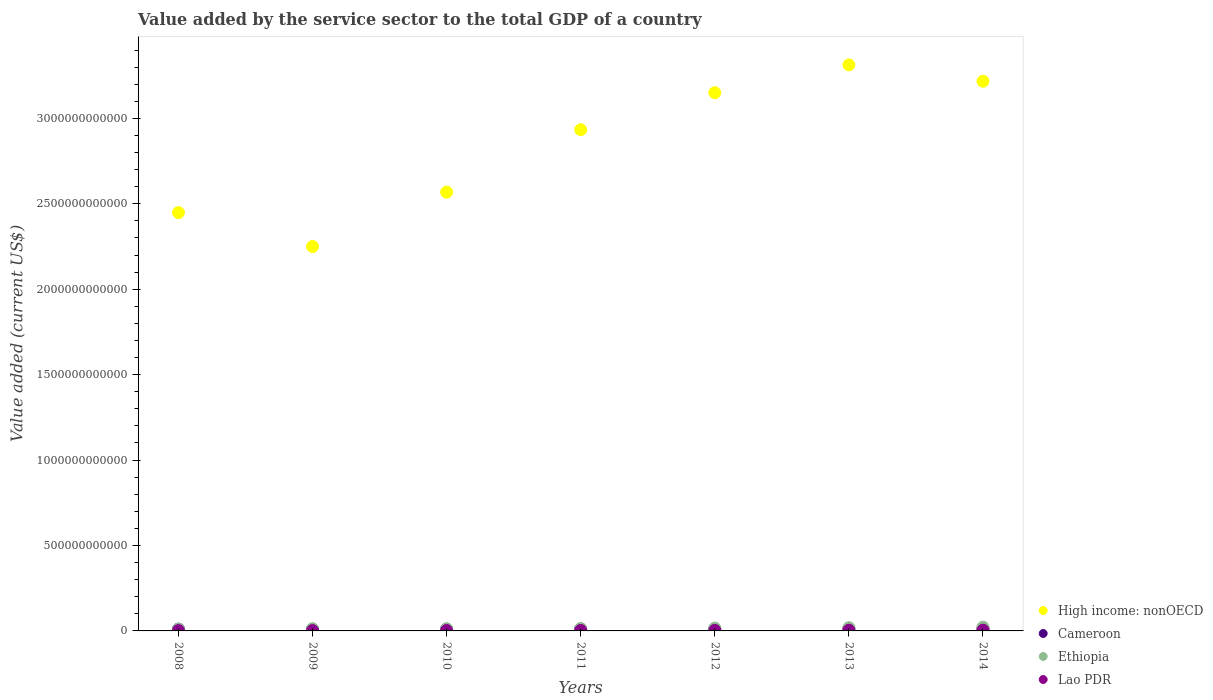How many different coloured dotlines are there?
Keep it short and to the point. 4. Is the number of dotlines equal to the number of legend labels?
Your answer should be compact. Yes. What is the value added by the service sector to the total GDP in Ethiopia in 2008?
Provide a succinct answer. 1.03e+1. Across all years, what is the maximum value added by the service sector to the total GDP in High income: nonOECD?
Give a very brief answer. 3.31e+12. Across all years, what is the minimum value added by the service sector to the total GDP in High income: nonOECD?
Provide a succinct answer. 2.25e+12. In which year was the value added by the service sector to the total GDP in Lao PDR minimum?
Offer a terse response. 2008. What is the total value added by the service sector to the total GDP in Lao PDR in the graph?
Your response must be concise. 2.12e+1. What is the difference between the value added by the service sector to the total GDP in Lao PDR in 2009 and that in 2012?
Offer a terse response. -1.06e+09. What is the difference between the value added by the service sector to the total GDP in High income: nonOECD in 2014 and the value added by the service sector to the total GDP in Lao PDR in 2008?
Give a very brief answer. 3.22e+12. What is the average value added by the service sector to the total GDP in Cameroon per year?
Ensure brevity in your answer.  1.15e+1. In the year 2014, what is the difference between the value added by the service sector to the total GDP in Ethiopia and value added by the service sector to the total GDP in High income: nonOECD?
Keep it short and to the point. -3.20e+12. In how many years, is the value added by the service sector to the total GDP in Cameroon greater than 1900000000000 US$?
Your response must be concise. 0. What is the ratio of the value added by the service sector to the total GDP in Ethiopia in 2009 to that in 2014?
Your answer should be very brief. 0.57. Is the value added by the service sector to the total GDP in Lao PDR in 2010 less than that in 2011?
Your answer should be very brief. Yes. Is the difference between the value added by the service sector to the total GDP in Ethiopia in 2012 and 2013 greater than the difference between the value added by the service sector to the total GDP in High income: nonOECD in 2012 and 2013?
Offer a very short reply. Yes. What is the difference between the highest and the second highest value added by the service sector to the total GDP in High income: nonOECD?
Provide a short and direct response. 9.57e+1. What is the difference between the highest and the lowest value added by the service sector to the total GDP in Ethiopia?
Ensure brevity in your answer.  1.19e+1. Is it the case that in every year, the sum of the value added by the service sector to the total GDP in High income: nonOECD and value added by the service sector to the total GDP in Cameroon  is greater than the sum of value added by the service sector to the total GDP in Ethiopia and value added by the service sector to the total GDP in Lao PDR?
Provide a succinct answer. No. Is it the case that in every year, the sum of the value added by the service sector to the total GDP in Cameroon and value added by the service sector to the total GDP in Ethiopia  is greater than the value added by the service sector to the total GDP in High income: nonOECD?
Your answer should be compact. No. Is the value added by the service sector to the total GDP in High income: nonOECD strictly greater than the value added by the service sector to the total GDP in Ethiopia over the years?
Your response must be concise. Yes. How many years are there in the graph?
Ensure brevity in your answer.  7. What is the difference between two consecutive major ticks on the Y-axis?
Provide a succinct answer. 5.00e+11. Are the values on the major ticks of Y-axis written in scientific E-notation?
Provide a succinct answer. No. Does the graph contain any zero values?
Offer a terse response. No. Where does the legend appear in the graph?
Give a very brief answer. Bottom right. How many legend labels are there?
Your response must be concise. 4. What is the title of the graph?
Your response must be concise. Value added by the service sector to the total GDP of a country. What is the label or title of the X-axis?
Provide a short and direct response. Years. What is the label or title of the Y-axis?
Your answer should be compact. Value added (current US$). What is the Value added (current US$) in High income: nonOECD in 2008?
Your response must be concise. 2.45e+12. What is the Value added (current US$) of Cameroon in 2008?
Keep it short and to the point. 1.02e+1. What is the Value added (current US$) of Ethiopia in 2008?
Provide a short and direct response. 1.03e+1. What is the Value added (current US$) in Lao PDR in 2008?
Ensure brevity in your answer.  1.88e+09. What is the Value added (current US$) in High income: nonOECD in 2009?
Offer a terse response. 2.25e+12. What is the Value added (current US$) in Cameroon in 2009?
Make the answer very short. 1.01e+1. What is the Value added (current US$) of Ethiopia in 2009?
Offer a terse response. 1.26e+1. What is the Value added (current US$) of Lao PDR in 2009?
Give a very brief answer. 2.11e+09. What is the Value added (current US$) of High income: nonOECD in 2010?
Your answer should be very brief. 2.57e+12. What is the Value added (current US$) in Cameroon in 2010?
Ensure brevity in your answer.  1.02e+1. What is the Value added (current US$) of Ethiopia in 2010?
Ensure brevity in your answer.  1.25e+1. What is the Value added (current US$) in Lao PDR in 2010?
Your answer should be compact. 2.40e+09. What is the Value added (current US$) in High income: nonOECD in 2011?
Give a very brief answer. 2.93e+12. What is the Value added (current US$) of Cameroon in 2011?
Give a very brief answer. 1.15e+1. What is the Value added (current US$) of Ethiopia in 2011?
Provide a short and direct response. 1.32e+1. What is the Value added (current US$) in Lao PDR in 2011?
Provide a succinct answer. 2.79e+09. What is the Value added (current US$) in High income: nonOECD in 2012?
Provide a succinct answer. 3.15e+12. What is the Value added (current US$) in Cameroon in 2012?
Your response must be concise. 1.14e+1. What is the Value added (current US$) of Ethiopia in 2012?
Your answer should be very brief. 1.67e+1. What is the Value added (current US$) in Lao PDR in 2012?
Your answer should be compact. 3.17e+09. What is the Value added (current US$) of High income: nonOECD in 2013?
Your response must be concise. 3.31e+12. What is the Value added (current US$) in Cameroon in 2013?
Your answer should be compact. 1.29e+1. What is the Value added (current US$) in Ethiopia in 2013?
Your response must be concise. 1.89e+1. What is the Value added (current US$) of Lao PDR in 2013?
Provide a succinct answer. 4.27e+09. What is the Value added (current US$) in High income: nonOECD in 2014?
Your answer should be compact. 3.22e+12. What is the Value added (current US$) of Cameroon in 2014?
Keep it short and to the point. 1.41e+1. What is the Value added (current US$) in Ethiopia in 2014?
Ensure brevity in your answer.  2.22e+1. What is the Value added (current US$) of Lao PDR in 2014?
Provide a succinct answer. 4.63e+09. Across all years, what is the maximum Value added (current US$) of High income: nonOECD?
Provide a short and direct response. 3.31e+12. Across all years, what is the maximum Value added (current US$) of Cameroon?
Your answer should be compact. 1.41e+1. Across all years, what is the maximum Value added (current US$) of Ethiopia?
Your answer should be compact. 2.22e+1. Across all years, what is the maximum Value added (current US$) of Lao PDR?
Provide a succinct answer. 4.63e+09. Across all years, what is the minimum Value added (current US$) in High income: nonOECD?
Make the answer very short. 2.25e+12. Across all years, what is the minimum Value added (current US$) of Cameroon?
Provide a short and direct response. 1.01e+1. Across all years, what is the minimum Value added (current US$) in Ethiopia?
Keep it short and to the point. 1.03e+1. Across all years, what is the minimum Value added (current US$) in Lao PDR?
Make the answer very short. 1.88e+09. What is the total Value added (current US$) of High income: nonOECD in the graph?
Your response must be concise. 1.99e+13. What is the total Value added (current US$) in Cameroon in the graph?
Your answer should be very brief. 8.04e+1. What is the total Value added (current US$) of Ethiopia in the graph?
Keep it short and to the point. 1.06e+11. What is the total Value added (current US$) of Lao PDR in the graph?
Provide a succinct answer. 2.12e+1. What is the difference between the Value added (current US$) in High income: nonOECD in 2008 and that in 2009?
Offer a very short reply. 1.99e+11. What is the difference between the Value added (current US$) of Cameroon in 2008 and that in 2009?
Your response must be concise. 1.82e+08. What is the difference between the Value added (current US$) in Ethiopia in 2008 and that in 2009?
Offer a very short reply. -2.32e+09. What is the difference between the Value added (current US$) in Lao PDR in 2008 and that in 2009?
Give a very brief answer. -2.29e+08. What is the difference between the Value added (current US$) in High income: nonOECD in 2008 and that in 2010?
Offer a terse response. -1.20e+11. What is the difference between the Value added (current US$) in Cameroon in 2008 and that in 2010?
Give a very brief answer. 2.34e+07. What is the difference between the Value added (current US$) in Ethiopia in 2008 and that in 2010?
Make the answer very short. -2.24e+09. What is the difference between the Value added (current US$) of Lao PDR in 2008 and that in 2010?
Give a very brief answer. -5.24e+08. What is the difference between the Value added (current US$) of High income: nonOECD in 2008 and that in 2011?
Your answer should be very brief. -4.85e+11. What is the difference between the Value added (current US$) in Cameroon in 2008 and that in 2011?
Give a very brief answer. -1.25e+09. What is the difference between the Value added (current US$) of Ethiopia in 2008 and that in 2011?
Keep it short and to the point. -2.98e+09. What is the difference between the Value added (current US$) of Lao PDR in 2008 and that in 2011?
Provide a short and direct response. -9.12e+08. What is the difference between the Value added (current US$) in High income: nonOECD in 2008 and that in 2012?
Your answer should be very brief. -7.02e+11. What is the difference between the Value added (current US$) of Cameroon in 2008 and that in 2012?
Your answer should be compact. -1.15e+09. What is the difference between the Value added (current US$) of Ethiopia in 2008 and that in 2012?
Keep it short and to the point. -6.45e+09. What is the difference between the Value added (current US$) in Lao PDR in 2008 and that in 2012?
Ensure brevity in your answer.  -1.29e+09. What is the difference between the Value added (current US$) in High income: nonOECD in 2008 and that in 2013?
Your answer should be very brief. -8.65e+11. What is the difference between the Value added (current US$) of Cameroon in 2008 and that in 2013?
Make the answer very short. -2.67e+09. What is the difference between the Value added (current US$) in Ethiopia in 2008 and that in 2013?
Keep it short and to the point. -8.64e+09. What is the difference between the Value added (current US$) of Lao PDR in 2008 and that in 2013?
Provide a short and direct response. -2.39e+09. What is the difference between the Value added (current US$) in High income: nonOECD in 2008 and that in 2014?
Provide a short and direct response. -7.69e+11. What is the difference between the Value added (current US$) in Cameroon in 2008 and that in 2014?
Keep it short and to the point. -3.84e+09. What is the difference between the Value added (current US$) of Ethiopia in 2008 and that in 2014?
Your answer should be very brief. -1.19e+1. What is the difference between the Value added (current US$) of Lao PDR in 2008 and that in 2014?
Your answer should be very brief. -2.75e+09. What is the difference between the Value added (current US$) in High income: nonOECD in 2009 and that in 2010?
Offer a very short reply. -3.18e+11. What is the difference between the Value added (current US$) in Cameroon in 2009 and that in 2010?
Provide a short and direct response. -1.58e+08. What is the difference between the Value added (current US$) of Ethiopia in 2009 and that in 2010?
Ensure brevity in your answer.  7.74e+07. What is the difference between the Value added (current US$) of Lao PDR in 2009 and that in 2010?
Your answer should be very brief. -2.95e+08. What is the difference between the Value added (current US$) in High income: nonOECD in 2009 and that in 2011?
Make the answer very short. -6.84e+11. What is the difference between the Value added (current US$) of Cameroon in 2009 and that in 2011?
Offer a very short reply. -1.43e+09. What is the difference between the Value added (current US$) of Ethiopia in 2009 and that in 2011?
Offer a terse response. -6.62e+08. What is the difference between the Value added (current US$) in Lao PDR in 2009 and that in 2011?
Your answer should be compact. -6.83e+08. What is the difference between the Value added (current US$) of High income: nonOECD in 2009 and that in 2012?
Make the answer very short. -9.00e+11. What is the difference between the Value added (current US$) in Cameroon in 2009 and that in 2012?
Your answer should be compact. -1.33e+09. What is the difference between the Value added (current US$) of Ethiopia in 2009 and that in 2012?
Offer a very short reply. -4.13e+09. What is the difference between the Value added (current US$) in Lao PDR in 2009 and that in 2012?
Make the answer very short. -1.06e+09. What is the difference between the Value added (current US$) in High income: nonOECD in 2009 and that in 2013?
Keep it short and to the point. -1.06e+12. What is the difference between the Value added (current US$) of Cameroon in 2009 and that in 2013?
Your answer should be compact. -2.85e+09. What is the difference between the Value added (current US$) in Ethiopia in 2009 and that in 2013?
Keep it short and to the point. -6.33e+09. What is the difference between the Value added (current US$) in Lao PDR in 2009 and that in 2013?
Give a very brief answer. -2.16e+09. What is the difference between the Value added (current US$) in High income: nonOECD in 2009 and that in 2014?
Your answer should be very brief. -9.68e+11. What is the difference between the Value added (current US$) of Cameroon in 2009 and that in 2014?
Make the answer very short. -4.02e+09. What is the difference between the Value added (current US$) in Ethiopia in 2009 and that in 2014?
Your answer should be compact. -9.61e+09. What is the difference between the Value added (current US$) in Lao PDR in 2009 and that in 2014?
Your response must be concise. -2.52e+09. What is the difference between the Value added (current US$) of High income: nonOECD in 2010 and that in 2011?
Your answer should be very brief. -3.66e+11. What is the difference between the Value added (current US$) of Cameroon in 2010 and that in 2011?
Give a very brief answer. -1.28e+09. What is the difference between the Value added (current US$) in Ethiopia in 2010 and that in 2011?
Ensure brevity in your answer.  -7.39e+08. What is the difference between the Value added (current US$) of Lao PDR in 2010 and that in 2011?
Give a very brief answer. -3.88e+08. What is the difference between the Value added (current US$) of High income: nonOECD in 2010 and that in 2012?
Offer a very short reply. -5.82e+11. What is the difference between the Value added (current US$) in Cameroon in 2010 and that in 2012?
Provide a short and direct response. -1.18e+09. What is the difference between the Value added (current US$) in Ethiopia in 2010 and that in 2012?
Your response must be concise. -4.21e+09. What is the difference between the Value added (current US$) of Lao PDR in 2010 and that in 2012?
Give a very brief answer. -7.68e+08. What is the difference between the Value added (current US$) in High income: nonOECD in 2010 and that in 2013?
Offer a terse response. -7.45e+11. What is the difference between the Value added (current US$) in Cameroon in 2010 and that in 2013?
Offer a terse response. -2.69e+09. What is the difference between the Value added (current US$) of Ethiopia in 2010 and that in 2013?
Provide a short and direct response. -6.40e+09. What is the difference between the Value added (current US$) in Lao PDR in 2010 and that in 2013?
Your answer should be very brief. -1.87e+09. What is the difference between the Value added (current US$) in High income: nonOECD in 2010 and that in 2014?
Your answer should be very brief. -6.49e+11. What is the difference between the Value added (current US$) of Cameroon in 2010 and that in 2014?
Make the answer very short. -3.86e+09. What is the difference between the Value added (current US$) of Ethiopia in 2010 and that in 2014?
Offer a very short reply. -9.69e+09. What is the difference between the Value added (current US$) of Lao PDR in 2010 and that in 2014?
Provide a short and direct response. -2.23e+09. What is the difference between the Value added (current US$) in High income: nonOECD in 2011 and that in 2012?
Give a very brief answer. -2.17e+11. What is the difference between the Value added (current US$) in Cameroon in 2011 and that in 2012?
Your answer should be very brief. 9.94e+07. What is the difference between the Value added (current US$) in Ethiopia in 2011 and that in 2012?
Your answer should be very brief. -3.47e+09. What is the difference between the Value added (current US$) of Lao PDR in 2011 and that in 2012?
Offer a terse response. -3.80e+08. What is the difference between the Value added (current US$) of High income: nonOECD in 2011 and that in 2013?
Offer a very short reply. -3.79e+11. What is the difference between the Value added (current US$) in Cameroon in 2011 and that in 2013?
Your answer should be very brief. -1.42e+09. What is the difference between the Value added (current US$) of Ethiopia in 2011 and that in 2013?
Your response must be concise. -5.66e+09. What is the difference between the Value added (current US$) in Lao PDR in 2011 and that in 2013?
Your answer should be compact. -1.48e+09. What is the difference between the Value added (current US$) of High income: nonOECD in 2011 and that in 2014?
Give a very brief answer. -2.84e+11. What is the difference between the Value added (current US$) of Cameroon in 2011 and that in 2014?
Your response must be concise. -2.58e+09. What is the difference between the Value added (current US$) of Ethiopia in 2011 and that in 2014?
Your response must be concise. -8.95e+09. What is the difference between the Value added (current US$) in Lao PDR in 2011 and that in 2014?
Provide a succinct answer. -1.84e+09. What is the difference between the Value added (current US$) in High income: nonOECD in 2012 and that in 2013?
Your answer should be very brief. -1.63e+11. What is the difference between the Value added (current US$) in Cameroon in 2012 and that in 2013?
Keep it short and to the point. -1.52e+09. What is the difference between the Value added (current US$) in Ethiopia in 2012 and that in 2013?
Give a very brief answer. -2.19e+09. What is the difference between the Value added (current US$) of Lao PDR in 2012 and that in 2013?
Your answer should be very brief. -1.10e+09. What is the difference between the Value added (current US$) of High income: nonOECD in 2012 and that in 2014?
Provide a short and direct response. -6.73e+1. What is the difference between the Value added (current US$) of Cameroon in 2012 and that in 2014?
Make the answer very short. -2.68e+09. What is the difference between the Value added (current US$) in Ethiopia in 2012 and that in 2014?
Ensure brevity in your answer.  -5.47e+09. What is the difference between the Value added (current US$) of Lao PDR in 2012 and that in 2014?
Make the answer very short. -1.46e+09. What is the difference between the Value added (current US$) of High income: nonOECD in 2013 and that in 2014?
Offer a terse response. 9.57e+1. What is the difference between the Value added (current US$) in Cameroon in 2013 and that in 2014?
Your response must be concise. -1.17e+09. What is the difference between the Value added (current US$) of Ethiopia in 2013 and that in 2014?
Your answer should be very brief. -3.28e+09. What is the difference between the Value added (current US$) in Lao PDR in 2013 and that in 2014?
Offer a terse response. -3.61e+08. What is the difference between the Value added (current US$) in High income: nonOECD in 2008 and the Value added (current US$) in Cameroon in 2009?
Your answer should be very brief. 2.44e+12. What is the difference between the Value added (current US$) of High income: nonOECD in 2008 and the Value added (current US$) of Ethiopia in 2009?
Offer a terse response. 2.44e+12. What is the difference between the Value added (current US$) in High income: nonOECD in 2008 and the Value added (current US$) in Lao PDR in 2009?
Your answer should be compact. 2.45e+12. What is the difference between the Value added (current US$) of Cameroon in 2008 and the Value added (current US$) of Ethiopia in 2009?
Provide a short and direct response. -2.34e+09. What is the difference between the Value added (current US$) of Cameroon in 2008 and the Value added (current US$) of Lao PDR in 2009?
Your answer should be compact. 8.13e+09. What is the difference between the Value added (current US$) in Ethiopia in 2008 and the Value added (current US$) in Lao PDR in 2009?
Your response must be concise. 8.15e+09. What is the difference between the Value added (current US$) in High income: nonOECD in 2008 and the Value added (current US$) in Cameroon in 2010?
Provide a succinct answer. 2.44e+12. What is the difference between the Value added (current US$) of High income: nonOECD in 2008 and the Value added (current US$) of Ethiopia in 2010?
Your answer should be very brief. 2.44e+12. What is the difference between the Value added (current US$) in High income: nonOECD in 2008 and the Value added (current US$) in Lao PDR in 2010?
Give a very brief answer. 2.45e+12. What is the difference between the Value added (current US$) of Cameroon in 2008 and the Value added (current US$) of Ethiopia in 2010?
Provide a succinct answer. -2.26e+09. What is the difference between the Value added (current US$) of Cameroon in 2008 and the Value added (current US$) of Lao PDR in 2010?
Provide a succinct answer. 7.84e+09. What is the difference between the Value added (current US$) of Ethiopia in 2008 and the Value added (current US$) of Lao PDR in 2010?
Offer a very short reply. 7.86e+09. What is the difference between the Value added (current US$) of High income: nonOECD in 2008 and the Value added (current US$) of Cameroon in 2011?
Give a very brief answer. 2.44e+12. What is the difference between the Value added (current US$) in High income: nonOECD in 2008 and the Value added (current US$) in Ethiopia in 2011?
Offer a very short reply. 2.44e+12. What is the difference between the Value added (current US$) in High income: nonOECD in 2008 and the Value added (current US$) in Lao PDR in 2011?
Provide a short and direct response. 2.45e+12. What is the difference between the Value added (current US$) in Cameroon in 2008 and the Value added (current US$) in Ethiopia in 2011?
Your response must be concise. -3.00e+09. What is the difference between the Value added (current US$) in Cameroon in 2008 and the Value added (current US$) in Lao PDR in 2011?
Ensure brevity in your answer.  7.45e+09. What is the difference between the Value added (current US$) in Ethiopia in 2008 and the Value added (current US$) in Lao PDR in 2011?
Provide a short and direct response. 7.47e+09. What is the difference between the Value added (current US$) of High income: nonOECD in 2008 and the Value added (current US$) of Cameroon in 2012?
Your response must be concise. 2.44e+12. What is the difference between the Value added (current US$) in High income: nonOECD in 2008 and the Value added (current US$) in Ethiopia in 2012?
Keep it short and to the point. 2.43e+12. What is the difference between the Value added (current US$) in High income: nonOECD in 2008 and the Value added (current US$) in Lao PDR in 2012?
Provide a short and direct response. 2.45e+12. What is the difference between the Value added (current US$) in Cameroon in 2008 and the Value added (current US$) in Ethiopia in 2012?
Provide a succinct answer. -6.47e+09. What is the difference between the Value added (current US$) of Cameroon in 2008 and the Value added (current US$) of Lao PDR in 2012?
Your answer should be very brief. 7.07e+09. What is the difference between the Value added (current US$) of Ethiopia in 2008 and the Value added (current US$) of Lao PDR in 2012?
Give a very brief answer. 7.09e+09. What is the difference between the Value added (current US$) of High income: nonOECD in 2008 and the Value added (current US$) of Cameroon in 2013?
Make the answer very short. 2.44e+12. What is the difference between the Value added (current US$) in High income: nonOECD in 2008 and the Value added (current US$) in Ethiopia in 2013?
Your response must be concise. 2.43e+12. What is the difference between the Value added (current US$) of High income: nonOECD in 2008 and the Value added (current US$) of Lao PDR in 2013?
Provide a succinct answer. 2.44e+12. What is the difference between the Value added (current US$) in Cameroon in 2008 and the Value added (current US$) in Ethiopia in 2013?
Make the answer very short. -8.66e+09. What is the difference between the Value added (current US$) in Cameroon in 2008 and the Value added (current US$) in Lao PDR in 2013?
Ensure brevity in your answer.  5.97e+09. What is the difference between the Value added (current US$) of Ethiopia in 2008 and the Value added (current US$) of Lao PDR in 2013?
Keep it short and to the point. 5.99e+09. What is the difference between the Value added (current US$) of High income: nonOECD in 2008 and the Value added (current US$) of Cameroon in 2014?
Give a very brief answer. 2.43e+12. What is the difference between the Value added (current US$) in High income: nonOECD in 2008 and the Value added (current US$) in Ethiopia in 2014?
Keep it short and to the point. 2.43e+12. What is the difference between the Value added (current US$) in High income: nonOECD in 2008 and the Value added (current US$) in Lao PDR in 2014?
Offer a very short reply. 2.44e+12. What is the difference between the Value added (current US$) of Cameroon in 2008 and the Value added (current US$) of Ethiopia in 2014?
Your answer should be very brief. -1.19e+1. What is the difference between the Value added (current US$) of Cameroon in 2008 and the Value added (current US$) of Lao PDR in 2014?
Offer a terse response. 5.61e+09. What is the difference between the Value added (current US$) in Ethiopia in 2008 and the Value added (current US$) in Lao PDR in 2014?
Ensure brevity in your answer.  5.63e+09. What is the difference between the Value added (current US$) in High income: nonOECD in 2009 and the Value added (current US$) in Cameroon in 2010?
Give a very brief answer. 2.24e+12. What is the difference between the Value added (current US$) of High income: nonOECD in 2009 and the Value added (current US$) of Ethiopia in 2010?
Provide a succinct answer. 2.24e+12. What is the difference between the Value added (current US$) of High income: nonOECD in 2009 and the Value added (current US$) of Lao PDR in 2010?
Your answer should be compact. 2.25e+12. What is the difference between the Value added (current US$) of Cameroon in 2009 and the Value added (current US$) of Ethiopia in 2010?
Provide a succinct answer. -2.44e+09. What is the difference between the Value added (current US$) in Cameroon in 2009 and the Value added (current US$) in Lao PDR in 2010?
Your answer should be compact. 7.65e+09. What is the difference between the Value added (current US$) of Ethiopia in 2009 and the Value added (current US$) of Lao PDR in 2010?
Your response must be concise. 1.02e+1. What is the difference between the Value added (current US$) of High income: nonOECD in 2009 and the Value added (current US$) of Cameroon in 2011?
Your answer should be compact. 2.24e+12. What is the difference between the Value added (current US$) of High income: nonOECD in 2009 and the Value added (current US$) of Ethiopia in 2011?
Provide a succinct answer. 2.24e+12. What is the difference between the Value added (current US$) of High income: nonOECD in 2009 and the Value added (current US$) of Lao PDR in 2011?
Your response must be concise. 2.25e+12. What is the difference between the Value added (current US$) of Cameroon in 2009 and the Value added (current US$) of Ethiopia in 2011?
Offer a very short reply. -3.18e+09. What is the difference between the Value added (current US$) of Cameroon in 2009 and the Value added (current US$) of Lao PDR in 2011?
Make the answer very short. 7.27e+09. What is the difference between the Value added (current US$) of Ethiopia in 2009 and the Value added (current US$) of Lao PDR in 2011?
Your answer should be compact. 9.79e+09. What is the difference between the Value added (current US$) of High income: nonOECD in 2009 and the Value added (current US$) of Cameroon in 2012?
Offer a terse response. 2.24e+12. What is the difference between the Value added (current US$) in High income: nonOECD in 2009 and the Value added (current US$) in Ethiopia in 2012?
Give a very brief answer. 2.23e+12. What is the difference between the Value added (current US$) in High income: nonOECD in 2009 and the Value added (current US$) in Lao PDR in 2012?
Your response must be concise. 2.25e+12. What is the difference between the Value added (current US$) in Cameroon in 2009 and the Value added (current US$) in Ethiopia in 2012?
Your response must be concise. -6.65e+09. What is the difference between the Value added (current US$) in Cameroon in 2009 and the Value added (current US$) in Lao PDR in 2012?
Make the answer very short. 6.89e+09. What is the difference between the Value added (current US$) of Ethiopia in 2009 and the Value added (current US$) of Lao PDR in 2012?
Your answer should be compact. 9.41e+09. What is the difference between the Value added (current US$) in High income: nonOECD in 2009 and the Value added (current US$) in Cameroon in 2013?
Give a very brief answer. 2.24e+12. What is the difference between the Value added (current US$) in High income: nonOECD in 2009 and the Value added (current US$) in Ethiopia in 2013?
Make the answer very short. 2.23e+12. What is the difference between the Value added (current US$) of High income: nonOECD in 2009 and the Value added (current US$) of Lao PDR in 2013?
Your response must be concise. 2.25e+12. What is the difference between the Value added (current US$) in Cameroon in 2009 and the Value added (current US$) in Ethiopia in 2013?
Your response must be concise. -8.85e+09. What is the difference between the Value added (current US$) of Cameroon in 2009 and the Value added (current US$) of Lao PDR in 2013?
Provide a short and direct response. 5.79e+09. What is the difference between the Value added (current US$) of Ethiopia in 2009 and the Value added (current US$) of Lao PDR in 2013?
Provide a short and direct response. 8.31e+09. What is the difference between the Value added (current US$) of High income: nonOECD in 2009 and the Value added (current US$) of Cameroon in 2014?
Offer a terse response. 2.24e+12. What is the difference between the Value added (current US$) in High income: nonOECD in 2009 and the Value added (current US$) in Ethiopia in 2014?
Provide a short and direct response. 2.23e+12. What is the difference between the Value added (current US$) in High income: nonOECD in 2009 and the Value added (current US$) in Lao PDR in 2014?
Give a very brief answer. 2.25e+12. What is the difference between the Value added (current US$) of Cameroon in 2009 and the Value added (current US$) of Ethiopia in 2014?
Give a very brief answer. -1.21e+1. What is the difference between the Value added (current US$) in Cameroon in 2009 and the Value added (current US$) in Lao PDR in 2014?
Make the answer very short. 5.43e+09. What is the difference between the Value added (current US$) of Ethiopia in 2009 and the Value added (current US$) of Lao PDR in 2014?
Your answer should be compact. 7.95e+09. What is the difference between the Value added (current US$) of High income: nonOECD in 2010 and the Value added (current US$) of Cameroon in 2011?
Give a very brief answer. 2.56e+12. What is the difference between the Value added (current US$) in High income: nonOECD in 2010 and the Value added (current US$) in Ethiopia in 2011?
Your response must be concise. 2.56e+12. What is the difference between the Value added (current US$) of High income: nonOECD in 2010 and the Value added (current US$) of Lao PDR in 2011?
Give a very brief answer. 2.57e+12. What is the difference between the Value added (current US$) of Cameroon in 2010 and the Value added (current US$) of Ethiopia in 2011?
Offer a very short reply. -3.02e+09. What is the difference between the Value added (current US$) of Cameroon in 2010 and the Value added (current US$) of Lao PDR in 2011?
Give a very brief answer. 7.42e+09. What is the difference between the Value added (current US$) of Ethiopia in 2010 and the Value added (current US$) of Lao PDR in 2011?
Offer a terse response. 9.71e+09. What is the difference between the Value added (current US$) of High income: nonOECD in 2010 and the Value added (current US$) of Cameroon in 2012?
Your answer should be very brief. 2.56e+12. What is the difference between the Value added (current US$) of High income: nonOECD in 2010 and the Value added (current US$) of Ethiopia in 2012?
Your response must be concise. 2.55e+12. What is the difference between the Value added (current US$) in High income: nonOECD in 2010 and the Value added (current US$) in Lao PDR in 2012?
Your answer should be very brief. 2.57e+12. What is the difference between the Value added (current US$) of Cameroon in 2010 and the Value added (current US$) of Ethiopia in 2012?
Your answer should be compact. -6.50e+09. What is the difference between the Value added (current US$) in Cameroon in 2010 and the Value added (current US$) in Lao PDR in 2012?
Your answer should be compact. 7.04e+09. What is the difference between the Value added (current US$) in Ethiopia in 2010 and the Value added (current US$) in Lao PDR in 2012?
Provide a succinct answer. 9.33e+09. What is the difference between the Value added (current US$) of High income: nonOECD in 2010 and the Value added (current US$) of Cameroon in 2013?
Offer a very short reply. 2.56e+12. What is the difference between the Value added (current US$) of High income: nonOECD in 2010 and the Value added (current US$) of Ethiopia in 2013?
Your answer should be very brief. 2.55e+12. What is the difference between the Value added (current US$) in High income: nonOECD in 2010 and the Value added (current US$) in Lao PDR in 2013?
Your answer should be very brief. 2.56e+12. What is the difference between the Value added (current US$) in Cameroon in 2010 and the Value added (current US$) in Ethiopia in 2013?
Offer a very short reply. -8.69e+09. What is the difference between the Value added (current US$) in Cameroon in 2010 and the Value added (current US$) in Lao PDR in 2013?
Keep it short and to the point. 5.95e+09. What is the difference between the Value added (current US$) in Ethiopia in 2010 and the Value added (current US$) in Lao PDR in 2013?
Ensure brevity in your answer.  8.23e+09. What is the difference between the Value added (current US$) of High income: nonOECD in 2010 and the Value added (current US$) of Cameroon in 2014?
Ensure brevity in your answer.  2.55e+12. What is the difference between the Value added (current US$) in High income: nonOECD in 2010 and the Value added (current US$) in Ethiopia in 2014?
Make the answer very short. 2.55e+12. What is the difference between the Value added (current US$) of High income: nonOECD in 2010 and the Value added (current US$) of Lao PDR in 2014?
Your answer should be very brief. 2.56e+12. What is the difference between the Value added (current US$) of Cameroon in 2010 and the Value added (current US$) of Ethiopia in 2014?
Provide a short and direct response. -1.20e+1. What is the difference between the Value added (current US$) in Cameroon in 2010 and the Value added (current US$) in Lao PDR in 2014?
Provide a short and direct response. 5.59e+09. What is the difference between the Value added (current US$) of Ethiopia in 2010 and the Value added (current US$) of Lao PDR in 2014?
Provide a succinct answer. 7.87e+09. What is the difference between the Value added (current US$) of High income: nonOECD in 2011 and the Value added (current US$) of Cameroon in 2012?
Your answer should be very brief. 2.92e+12. What is the difference between the Value added (current US$) of High income: nonOECD in 2011 and the Value added (current US$) of Ethiopia in 2012?
Your answer should be compact. 2.92e+12. What is the difference between the Value added (current US$) of High income: nonOECD in 2011 and the Value added (current US$) of Lao PDR in 2012?
Provide a short and direct response. 2.93e+12. What is the difference between the Value added (current US$) of Cameroon in 2011 and the Value added (current US$) of Ethiopia in 2012?
Offer a terse response. -5.22e+09. What is the difference between the Value added (current US$) in Cameroon in 2011 and the Value added (current US$) in Lao PDR in 2012?
Provide a short and direct response. 8.32e+09. What is the difference between the Value added (current US$) in Ethiopia in 2011 and the Value added (current US$) in Lao PDR in 2012?
Your answer should be compact. 1.01e+1. What is the difference between the Value added (current US$) of High income: nonOECD in 2011 and the Value added (current US$) of Cameroon in 2013?
Provide a short and direct response. 2.92e+12. What is the difference between the Value added (current US$) in High income: nonOECD in 2011 and the Value added (current US$) in Ethiopia in 2013?
Your response must be concise. 2.91e+12. What is the difference between the Value added (current US$) in High income: nonOECD in 2011 and the Value added (current US$) in Lao PDR in 2013?
Give a very brief answer. 2.93e+12. What is the difference between the Value added (current US$) of Cameroon in 2011 and the Value added (current US$) of Ethiopia in 2013?
Your answer should be compact. -7.41e+09. What is the difference between the Value added (current US$) of Cameroon in 2011 and the Value added (current US$) of Lao PDR in 2013?
Offer a very short reply. 7.22e+09. What is the difference between the Value added (current US$) in Ethiopia in 2011 and the Value added (current US$) in Lao PDR in 2013?
Your answer should be very brief. 8.97e+09. What is the difference between the Value added (current US$) of High income: nonOECD in 2011 and the Value added (current US$) of Cameroon in 2014?
Ensure brevity in your answer.  2.92e+12. What is the difference between the Value added (current US$) in High income: nonOECD in 2011 and the Value added (current US$) in Ethiopia in 2014?
Keep it short and to the point. 2.91e+12. What is the difference between the Value added (current US$) of High income: nonOECD in 2011 and the Value added (current US$) of Lao PDR in 2014?
Provide a succinct answer. 2.93e+12. What is the difference between the Value added (current US$) of Cameroon in 2011 and the Value added (current US$) of Ethiopia in 2014?
Provide a succinct answer. -1.07e+1. What is the difference between the Value added (current US$) of Cameroon in 2011 and the Value added (current US$) of Lao PDR in 2014?
Make the answer very short. 6.86e+09. What is the difference between the Value added (current US$) of Ethiopia in 2011 and the Value added (current US$) of Lao PDR in 2014?
Your response must be concise. 8.61e+09. What is the difference between the Value added (current US$) of High income: nonOECD in 2012 and the Value added (current US$) of Cameroon in 2013?
Your answer should be very brief. 3.14e+12. What is the difference between the Value added (current US$) in High income: nonOECD in 2012 and the Value added (current US$) in Ethiopia in 2013?
Keep it short and to the point. 3.13e+12. What is the difference between the Value added (current US$) in High income: nonOECD in 2012 and the Value added (current US$) in Lao PDR in 2013?
Offer a terse response. 3.15e+12. What is the difference between the Value added (current US$) of Cameroon in 2012 and the Value added (current US$) of Ethiopia in 2013?
Offer a terse response. -7.51e+09. What is the difference between the Value added (current US$) in Cameroon in 2012 and the Value added (current US$) in Lao PDR in 2013?
Provide a succinct answer. 7.12e+09. What is the difference between the Value added (current US$) in Ethiopia in 2012 and the Value added (current US$) in Lao PDR in 2013?
Ensure brevity in your answer.  1.24e+1. What is the difference between the Value added (current US$) of High income: nonOECD in 2012 and the Value added (current US$) of Cameroon in 2014?
Offer a terse response. 3.14e+12. What is the difference between the Value added (current US$) of High income: nonOECD in 2012 and the Value added (current US$) of Ethiopia in 2014?
Make the answer very short. 3.13e+12. What is the difference between the Value added (current US$) in High income: nonOECD in 2012 and the Value added (current US$) in Lao PDR in 2014?
Your answer should be very brief. 3.15e+12. What is the difference between the Value added (current US$) of Cameroon in 2012 and the Value added (current US$) of Ethiopia in 2014?
Keep it short and to the point. -1.08e+1. What is the difference between the Value added (current US$) in Cameroon in 2012 and the Value added (current US$) in Lao PDR in 2014?
Your answer should be compact. 6.76e+09. What is the difference between the Value added (current US$) of Ethiopia in 2012 and the Value added (current US$) of Lao PDR in 2014?
Offer a very short reply. 1.21e+1. What is the difference between the Value added (current US$) of High income: nonOECD in 2013 and the Value added (current US$) of Cameroon in 2014?
Your response must be concise. 3.30e+12. What is the difference between the Value added (current US$) of High income: nonOECD in 2013 and the Value added (current US$) of Ethiopia in 2014?
Offer a very short reply. 3.29e+12. What is the difference between the Value added (current US$) of High income: nonOECD in 2013 and the Value added (current US$) of Lao PDR in 2014?
Provide a succinct answer. 3.31e+12. What is the difference between the Value added (current US$) in Cameroon in 2013 and the Value added (current US$) in Ethiopia in 2014?
Your answer should be compact. -9.28e+09. What is the difference between the Value added (current US$) of Cameroon in 2013 and the Value added (current US$) of Lao PDR in 2014?
Your response must be concise. 8.28e+09. What is the difference between the Value added (current US$) in Ethiopia in 2013 and the Value added (current US$) in Lao PDR in 2014?
Your response must be concise. 1.43e+1. What is the average Value added (current US$) of High income: nonOECD per year?
Your answer should be very brief. 2.84e+12. What is the average Value added (current US$) in Cameroon per year?
Offer a terse response. 1.15e+1. What is the average Value added (current US$) of Ethiopia per year?
Provide a short and direct response. 1.52e+1. What is the average Value added (current US$) in Lao PDR per year?
Offer a very short reply. 3.04e+09. In the year 2008, what is the difference between the Value added (current US$) of High income: nonOECD and Value added (current US$) of Cameroon?
Ensure brevity in your answer.  2.44e+12. In the year 2008, what is the difference between the Value added (current US$) in High income: nonOECD and Value added (current US$) in Ethiopia?
Give a very brief answer. 2.44e+12. In the year 2008, what is the difference between the Value added (current US$) of High income: nonOECD and Value added (current US$) of Lao PDR?
Give a very brief answer. 2.45e+12. In the year 2008, what is the difference between the Value added (current US$) in Cameroon and Value added (current US$) in Ethiopia?
Your answer should be very brief. -2.04e+07. In the year 2008, what is the difference between the Value added (current US$) of Cameroon and Value added (current US$) of Lao PDR?
Provide a short and direct response. 8.36e+09. In the year 2008, what is the difference between the Value added (current US$) of Ethiopia and Value added (current US$) of Lao PDR?
Give a very brief answer. 8.38e+09. In the year 2009, what is the difference between the Value added (current US$) of High income: nonOECD and Value added (current US$) of Cameroon?
Provide a short and direct response. 2.24e+12. In the year 2009, what is the difference between the Value added (current US$) in High income: nonOECD and Value added (current US$) in Ethiopia?
Make the answer very short. 2.24e+12. In the year 2009, what is the difference between the Value added (current US$) of High income: nonOECD and Value added (current US$) of Lao PDR?
Your answer should be very brief. 2.25e+12. In the year 2009, what is the difference between the Value added (current US$) of Cameroon and Value added (current US$) of Ethiopia?
Offer a terse response. -2.52e+09. In the year 2009, what is the difference between the Value added (current US$) of Cameroon and Value added (current US$) of Lao PDR?
Your response must be concise. 7.95e+09. In the year 2009, what is the difference between the Value added (current US$) in Ethiopia and Value added (current US$) in Lao PDR?
Provide a succinct answer. 1.05e+1. In the year 2010, what is the difference between the Value added (current US$) of High income: nonOECD and Value added (current US$) of Cameroon?
Provide a short and direct response. 2.56e+12. In the year 2010, what is the difference between the Value added (current US$) in High income: nonOECD and Value added (current US$) in Ethiopia?
Provide a succinct answer. 2.56e+12. In the year 2010, what is the difference between the Value added (current US$) in High income: nonOECD and Value added (current US$) in Lao PDR?
Make the answer very short. 2.57e+12. In the year 2010, what is the difference between the Value added (current US$) in Cameroon and Value added (current US$) in Ethiopia?
Your response must be concise. -2.28e+09. In the year 2010, what is the difference between the Value added (current US$) of Cameroon and Value added (current US$) of Lao PDR?
Offer a very short reply. 7.81e+09. In the year 2010, what is the difference between the Value added (current US$) in Ethiopia and Value added (current US$) in Lao PDR?
Keep it short and to the point. 1.01e+1. In the year 2011, what is the difference between the Value added (current US$) of High income: nonOECD and Value added (current US$) of Cameroon?
Offer a terse response. 2.92e+12. In the year 2011, what is the difference between the Value added (current US$) of High income: nonOECD and Value added (current US$) of Ethiopia?
Offer a very short reply. 2.92e+12. In the year 2011, what is the difference between the Value added (current US$) of High income: nonOECD and Value added (current US$) of Lao PDR?
Provide a short and direct response. 2.93e+12. In the year 2011, what is the difference between the Value added (current US$) of Cameroon and Value added (current US$) of Ethiopia?
Make the answer very short. -1.75e+09. In the year 2011, what is the difference between the Value added (current US$) in Cameroon and Value added (current US$) in Lao PDR?
Offer a terse response. 8.70e+09. In the year 2011, what is the difference between the Value added (current US$) in Ethiopia and Value added (current US$) in Lao PDR?
Ensure brevity in your answer.  1.04e+1. In the year 2012, what is the difference between the Value added (current US$) of High income: nonOECD and Value added (current US$) of Cameroon?
Give a very brief answer. 3.14e+12. In the year 2012, what is the difference between the Value added (current US$) of High income: nonOECD and Value added (current US$) of Ethiopia?
Make the answer very short. 3.13e+12. In the year 2012, what is the difference between the Value added (current US$) in High income: nonOECD and Value added (current US$) in Lao PDR?
Ensure brevity in your answer.  3.15e+12. In the year 2012, what is the difference between the Value added (current US$) of Cameroon and Value added (current US$) of Ethiopia?
Ensure brevity in your answer.  -5.32e+09. In the year 2012, what is the difference between the Value added (current US$) in Cameroon and Value added (current US$) in Lao PDR?
Provide a succinct answer. 8.22e+09. In the year 2012, what is the difference between the Value added (current US$) in Ethiopia and Value added (current US$) in Lao PDR?
Make the answer very short. 1.35e+1. In the year 2013, what is the difference between the Value added (current US$) of High income: nonOECD and Value added (current US$) of Cameroon?
Provide a short and direct response. 3.30e+12. In the year 2013, what is the difference between the Value added (current US$) in High income: nonOECD and Value added (current US$) in Ethiopia?
Your answer should be very brief. 3.29e+12. In the year 2013, what is the difference between the Value added (current US$) in High income: nonOECD and Value added (current US$) in Lao PDR?
Provide a short and direct response. 3.31e+12. In the year 2013, what is the difference between the Value added (current US$) in Cameroon and Value added (current US$) in Ethiopia?
Ensure brevity in your answer.  -5.99e+09. In the year 2013, what is the difference between the Value added (current US$) in Cameroon and Value added (current US$) in Lao PDR?
Provide a short and direct response. 8.64e+09. In the year 2013, what is the difference between the Value added (current US$) of Ethiopia and Value added (current US$) of Lao PDR?
Provide a short and direct response. 1.46e+1. In the year 2014, what is the difference between the Value added (current US$) of High income: nonOECD and Value added (current US$) of Cameroon?
Give a very brief answer. 3.20e+12. In the year 2014, what is the difference between the Value added (current US$) in High income: nonOECD and Value added (current US$) in Ethiopia?
Give a very brief answer. 3.20e+12. In the year 2014, what is the difference between the Value added (current US$) in High income: nonOECD and Value added (current US$) in Lao PDR?
Your response must be concise. 3.21e+12. In the year 2014, what is the difference between the Value added (current US$) of Cameroon and Value added (current US$) of Ethiopia?
Offer a very short reply. -8.11e+09. In the year 2014, what is the difference between the Value added (current US$) of Cameroon and Value added (current US$) of Lao PDR?
Your answer should be compact. 9.44e+09. In the year 2014, what is the difference between the Value added (current US$) of Ethiopia and Value added (current US$) of Lao PDR?
Your response must be concise. 1.76e+1. What is the ratio of the Value added (current US$) of High income: nonOECD in 2008 to that in 2009?
Offer a terse response. 1.09. What is the ratio of the Value added (current US$) of Ethiopia in 2008 to that in 2009?
Give a very brief answer. 0.82. What is the ratio of the Value added (current US$) of Lao PDR in 2008 to that in 2009?
Give a very brief answer. 0.89. What is the ratio of the Value added (current US$) in High income: nonOECD in 2008 to that in 2010?
Offer a very short reply. 0.95. What is the ratio of the Value added (current US$) in Cameroon in 2008 to that in 2010?
Your answer should be very brief. 1. What is the ratio of the Value added (current US$) of Ethiopia in 2008 to that in 2010?
Offer a very short reply. 0.82. What is the ratio of the Value added (current US$) of Lao PDR in 2008 to that in 2010?
Offer a very short reply. 0.78. What is the ratio of the Value added (current US$) in High income: nonOECD in 2008 to that in 2011?
Provide a short and direct response. 0.83. What is the ratio of the Value added (current US$) of Cameroon in 2008 to that in 2011?
Your response must be concise. 0.89. What is the ratio of the Value added (current US$) in Ethiopia in 2008 to that in 2011?
Make the answer very short. 0.77. What is the ratio of the Value added (current US$) in Lao PDR in 2008 to that in 2011?
Ensure brevity in your answer.  0.67. What is the ratio of the Value added (current US$) of High income: nonOECD in 2008 to that in 2012?
Ensure brevity in your answer.  0.78. What is the ratio of the Value added (current US$) in Cameroon in 2008 to that in 2012?
Your answer should be compact. 0.9. What is the ratio of the Value added (current US$) of Ethiopia in 2008 to that in 2012?
Give a very brief answer. 0.61. What is the ratio of the Value added (current US$) of Lao PDR in 2008 to that in 2012?
Keep it short and to the point. 0.59. What is the ratio of the Value added (current US$) of High income: nonOECD in 2008 to that in 2013?
Keep it short and to the point. 0.74. What is the ratio of the Value added (current US$) in Cameroon in 2008 to that in 2013?
Make the answer very short. 0.79. What is the ratio of the Value added (current US$) in Ethiopia in 2008 to that in 2013?
Offer a terse response. 0.54. What is the ratio of the Value added (current US$) of Lao PDR in 2008 to that in 2013?
Give a very brief answer. 0.44. What is the ratio of the Value added (current US$) of High income: nonOECD in 2008 to that in 2014?
Your answer should be compact. 0.76. What is the ratio of the Value added (current US$) in Cameroon in 2008 to that in 2014?
Give a very brief answer. 0.73. What is the ratio of the Value added (current US$) in Ethiopia in 2008 to that in 2014?
Make the answer very short. 0.46. What is the ratio of the Value added (current US$) of Lao PDR in 2008 to that in 2014?
Your answer should be compact. 0.41. What is the ratio of the Value added (current US$) in High income: nonOECD in 2009 to that in 2010?
Provide a short and direct response. 0.88. What is the ratio of the Value added (current US$) in Cameroon in 2009 to that in 2010?
Ensure brevity in your answer.  0.98. What is the ratio of the Value added (current US$) of Lao PDR in 2009 to that in 2010?
Your answer should be compact. 0.88. What is the ratio of the Value added (current US$) of High income: nonOECD in 2009 to that in 2011?
Your answer should be compact. 0.77. What is the ratio of the Value added (current US$) in Cameroon in 2009 to that in 2011?
Make the answer very short. 0.88. What is the ratio of the Value added (current US$) in Lao PDR in 2009 to that in 2011?
Give a very brief answer. 0.76. What is the ratio of the Value added (current US$) in High income: nonOECD in 2009 to that in 2012?
Your answer should be very brief. 0.71. What is the ratio of the Value added (current US$) in Cameroon in 2009 to that in 2012?
Provide a succinct answer. 0.88. What is the ratio of the Value added (current US$) of Ethiopia in 2009 to that in 2012?
Provide a short and direct response. 0.75. What is the ratio of the Value added (current US$) in Lao PDR in 2009 to that in 2012?
Provide a succinct answer. 0.66. What is the ratio of the Value added (current US$) of High income: nonOECD in 2009 to that in 2013?
Give a very brief answer. 0.68. What is the ratio of the Value added (current US$) of Cameroon in 2009 to that in 2013?
Give a very brief answer. 0.78. What is the ratio of the Value added (current US$) of Ethiopia in 2009 to that in 2013?
Provide a succinct answer. 0.67. What is the ratio of the Value added (current US$) in Lao PDR in 2009 to that in 2013?
Your response must be concise. 0.49. What is the ratio of the Value added (current US$) of High income: nonOECD in 2009 to that in 2014?
Offer a very short reply. 0.7. What is the ratio of the Value added (current US$) of Cameroon in 2009 to that in 2014?
Your response must be concise. 0.71. What is the ratio of the Value added (current US$) of Ethiopia in 2009 to that in 2014?
Provide a short and direct response. 0.57. What is the ratio of the Value added (current US$) in Lao PDR in 2009 to that in 2014?
Make the answer very short. 0.46. What is the ratio of the Value added (current US$) of High income: nonOECD in 2010 to that in 2011?
Make the answer very short. 0.88. What is the ratio of the Value added (current US$) of Cameroon in 2010 to that in 2011?
Ensure brevity in your answer.  0.89. What is the ratio of the Value added (current US$) of Ethiopia in 2010 to that in 2011?
Make the answer very short. 0.94. What is the ratio of the Value added (current US$) of Lao PDR in 2010 to that in 2011?
Ensure brevity in your answer.  0.86. What is the ratio of the Value added (current US$) in High income: nonOECD in 2010 to that in 2012?
Your response must be concise. 0.82. What is the ratio of the Value added (current US$) in Cameroon in 2010 to that in 2012?
Offer a very short reply. 0.9. What is the ratio of the Value added (current US$) in Ethiopia in 2010 to that in 2012?
Your response must be concise. 0.75. What is the ratio of the Value added (current US$) of Lao PDR in 2010 to that in 2012?
Your answer should be compact. 0.76. What is the ratio of the Value added (current US$) in High income: nonOECD in 2010 to that in 2013?
Offer a very short reply. 0.78. What is the ratio of the Value added (current US$) of Cameroon in 2010 to that in 2013?
Provide a succinct answer. 0.79. What is the ratio of the Value added (current US$) of Ethiopia in 2010 to that in 2013?
Your answer should be very brief. 0.66. What is the ratio of the Value added (current US$) in Lao PDR in 2010 to that in 2013?
Provide a short and direct response. 0.56. What is the ratio of the Value added (current US$) of High income: nonOECD in 2010 to that in 2014?
Provide a short and direct response. 0.8. What is the ratio of the Value added (current US$) of Cameroon in 2010 to that in 2014?
Provide a short and direct response. 0.73. What is the ratio of the Value added (current US$) of Ethiopia in 2010 to that in 2014?
Your response must be concise. 0.56. What is the ratio of the Value added (current US$) of Lao PDR in 2010 to that in 2014?
Your answer should be very brief. 0.52. What is the ratio of the Value added (current US$) in High income: nonOECD in 2011 to that in 2012?
Provide a short and direct response. 0.93. What is the ratio of the Value added (current US$) in Cameroon in 2011 to that in 2012?
Offer a very short reply. 1.01. What is the ratio of the Value added (current US$) in Ethiopia in 2011 to that in 2012?
Offer a terse response. 0.79. What is the ratio of the Value added (current US$) in Lao PDR in 2011 to that in 2012?
Your answer should be compact. 0.88. What is the ratio of the Value added (current US$) of High income: nonOECD in 2011 to that in 2013?
Give a very brief answer. 0.89. What is the ratio of the Value added (current US$) in Cameroon in 2011 to that in 2013?
Provide a succinct answer. 0.89. What is the ratio of the Value added (current US$) in Ethiopia in 2011 to that in 2013?
Ensure brevity in your answer.  0.7. What is the ratio of the Value added (current US$) of Lao PDR in 2011 to that in 2013?
Your answer should be compact. 0.65. What is the ratio of the Value added (current US$) in High income: nonOECD in 2011 to that in 2014?
Offer a very short reply. 0.91. What is the ratio of the Value added (current US$) in Cameroon in 2011 to that in 2014?
Your answer should be very brief. 0.82. What is the ratio of the Value added (current US$) in Ethiopia in 2011 to that in 2014?
Your answer should be compact. 0.6. What is the ratio of the Value added (current US$) of Lao PDR in 2011 to that in 2014?
Give a very brief answer. 0.6. What is the ratio of the Value added (current US$) in High income: nonOECD in 2012 to that in 2013?
Provide a succinct answer. 0.95. What is the ratio of the Value added (current US$) of Cameroon in 2012 to that in 2013?
Provide a succinct answer. 0.88. What is the ratio of the Value added (current US$) of Ethiopia in 2012 to that in 2013?
Your answer should be very brief. 0.88. What is the ratio of the Value added (current US$) in Lao PDR in 2012 to that in 2013?
Your answer should be compact. 0.74. What is the ratio of the Value added (current US$) in High income: nonOECD in 2012 to that in 2014?
Provide a short and direct response. 0.98. What is the ratio of the Value added (current US$) of Cameroon in 2012 to that in 2014?
Ensure brevity in your answer.  0.81. What is the ratio of the Value added (current US$) of Ethiopia in 2012 to that in 2014?
Offer a terse response. 0.75. What is the ratio of the Value added (current US$) of Lao PDR in 2012 to that in 2014?
Make the answer very short. 0.68. What is the ratio of the Value added (current US$) in High income: nonOECD in 2013 to that in 2014?
Ensure brevity in your answer.  1.03. What is the ratio of the Value added (current US$) of Cameroon in 2013 to that in 2014?
Keep it short and to the point. 0.92. What is the ratio of the Value added (current US$) in Ethiopia in 2013 to that in 2014?
Offer a very short reply. 0.85. What is the ratio of the Value added (current US$) of Lao PDR in 2013 to that in 2014?
Offer a terse response. 0.92. What is the difference between the highest and the second highest Value added (current US$) in High income: nonOECD?
Keep it short and to the point. 9.57e+1. What is the difference between the highest and the second highest Value added (current US$) in Cameroon?
Your answer should be compact. 1.17e+09. What is the difference between the highest and the second highest Value added (current US$) of Ethiopia?
Your response must be concise. 3.28e+09. What is the difference between the highest and the second highest Value added (current US$) of Lao PDR?
Provide a succinct answer. 3.61e+08. What is the difference between the highest and the lowest Value added (current US$) in High income: nonOECD?
Provide a succinct answer. 1.06e+12. What is the difference between the highest and the lowest Value added (current US$) of Cameroon?
Ensure brevity in your answer.  4.02e+09. What is the difference between the highest and the lowest Value added (current US$) in Ethiopia?
Offer a terse response. 1.19e+1. What is the difference between the highest and the lowest Value added (current US$) in Lao PDR?
Offer a very short reply. 2.75e+09. 